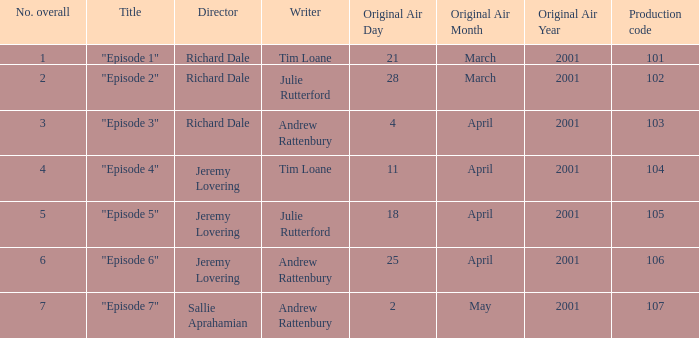When did the episodes first air that had a production code of 107? 2May2001. 